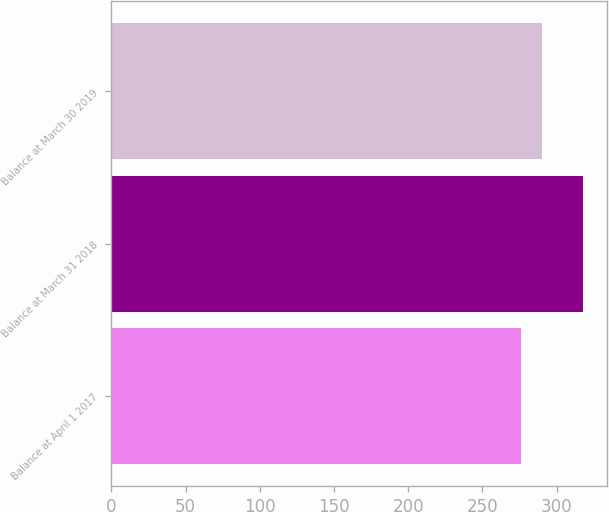Convert chart. <chart><loc_0><loc_0><loc_500><loc_500><bar_chart><fcel>Balance at April 1 2017<fcel>Balance at March 31 2018<fcel>Balance at March 30 2019<nl><fcel>275.9<fcel>317.9<fcel>290<nl></chart> 